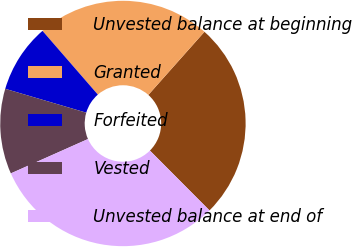<chart> <loc_0><loc_0><loc_500><loc_500><pie_chart><fcel>Unvested balance at beginning<fcel>Granted<fcel>Forfeited<fcel>Vested<fcel>Unvested balance at end of<nl><fcel>25.97%<fcel>22.95%<fcel>9.06%<fcel>11.23%<fcel>30.8%<nl></chart> 